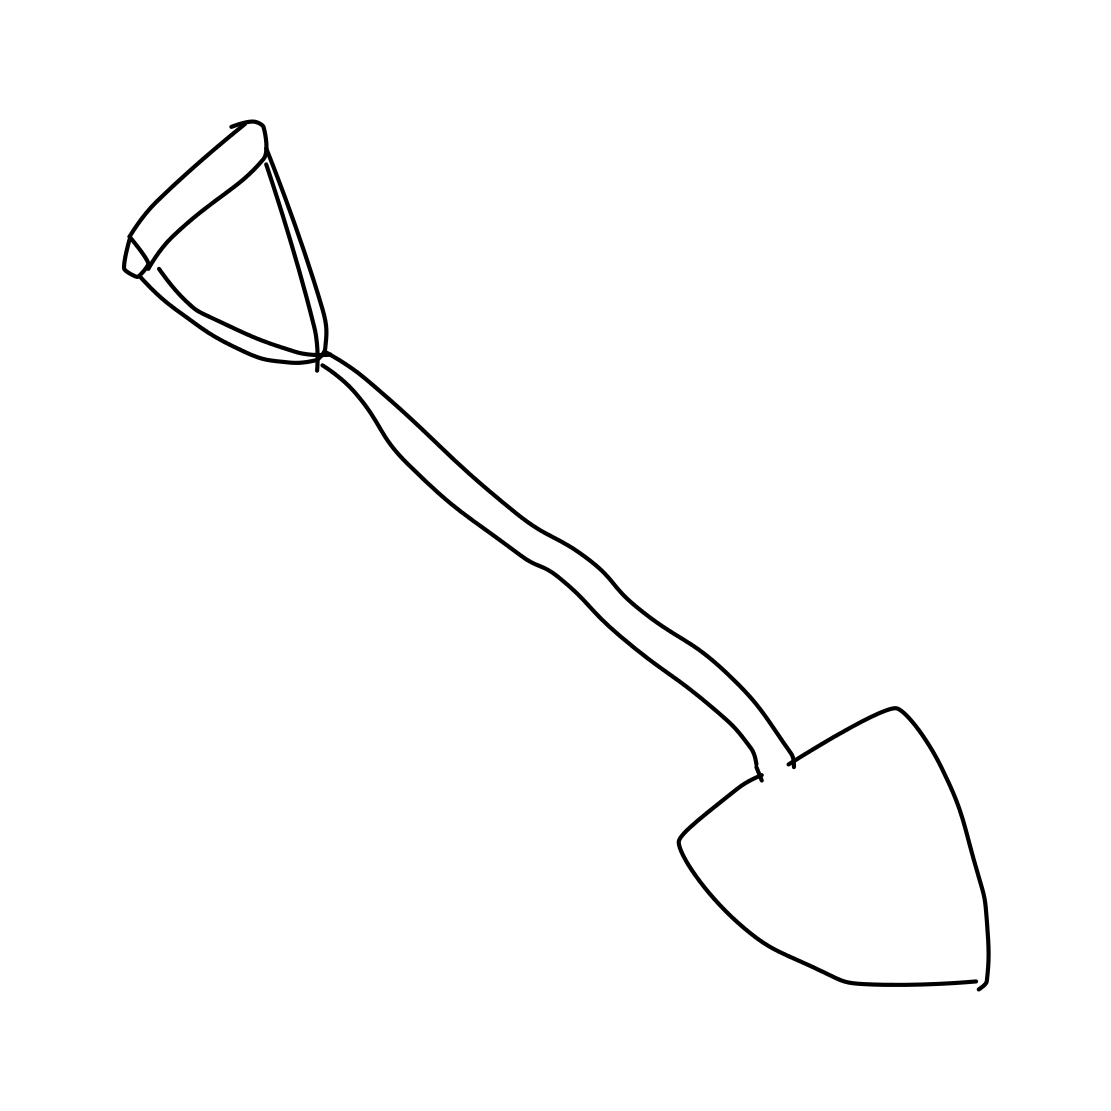What could this shovel be used for? This shovel, with its pointed tip, seems ideal for breaking into tough soil or digging small holes for planting. It's a common tool for gardeners or anyone involved in minor excavation work. 